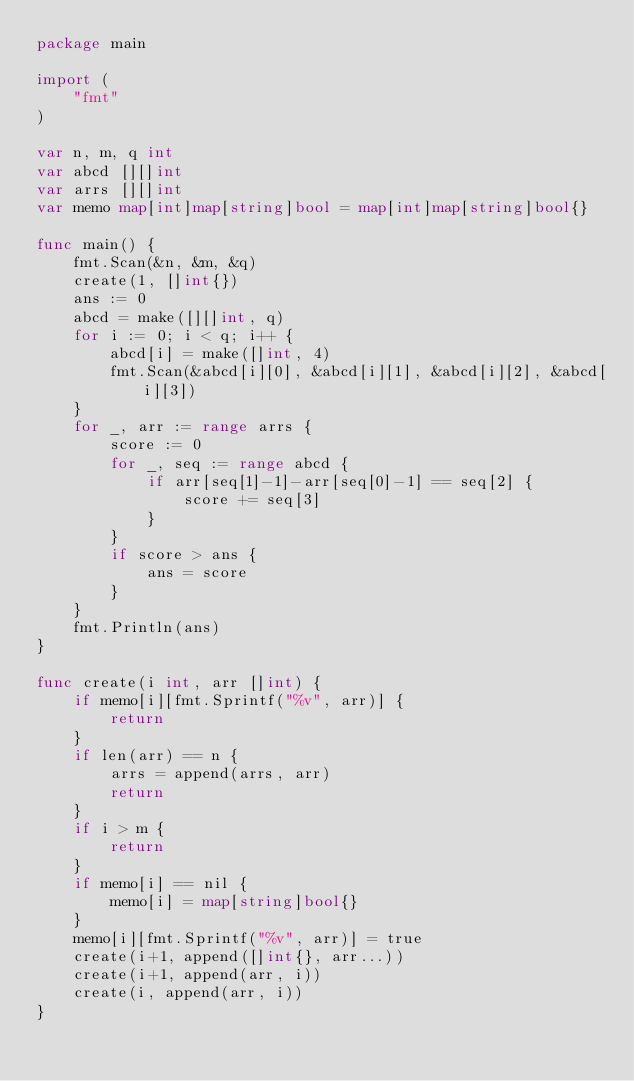Convert code to text. <code><loc_0><loc_0><loc_500><loc_500><_Go_>package main

import (
	"fmt"
)

var n, m, q int
var abcd [][]int
var arrs [][]int
var memo map[int]map[string]bool = map[int]map[string]bool{}

func main() {
	fmt.Scan(&n, &m, &q)
	create(1, []int{})
	ans := 0
	abcd = make([][]int, q)
	for i := 0; i < q; i++ {
		abcd[i] = make([]int, 4)
		fmt.Scan(&abcd[i][0], &abcd[i][1], &abcd[i][2], &abcd[i][3])
	}
	for _, arr := range arrs {
		score := 0
		for _, seq := range abcd {
			if arr[seq[1]-1]-arr[seq[0]-1] == seq[2] {
				score += seq[3]
			}
		}
		if score > ans {
			ans = score
		}
	}
	fmt.Println(ans)
}

func create(i int, arr []int) {
	if memo[i][fmt.Sprintf("%v", arr)] {
		return
	}
	if len(arr) == n {
		arrs = append(arrs, arr)
		return
	}
	if i > m {
		return
	}
	if memo[i] == nil {
		memo[i] = map[string]bool{}
	}
	memo[i][fmt.Sprintf("%v", arr)] = true
	create(i+1, append([]int{}, arr...))
	create(i+1, append(arr, i))
	create(i, append(arr, i))
}
</code> 